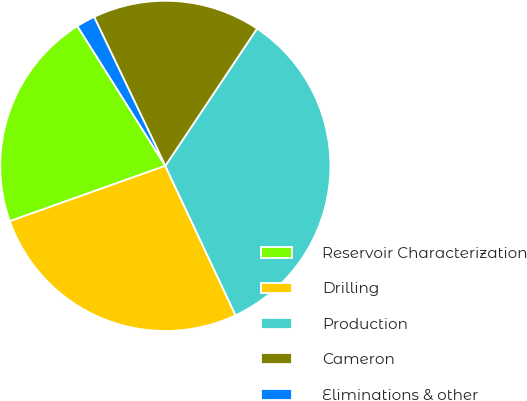Convert chart. <chart><loc_0><loc_0><loc_500><loc_500><pie_chart><fcel>Reservoir Characterization<fcel>Drilling<fcel>Production<fcel>Cameron<fcel>Eliminations & other<nl><fcel>21.5%<fcel>26.55%<fcel>33.63%<fcel>16.47%<fcel>1.84%<nl></chart> 